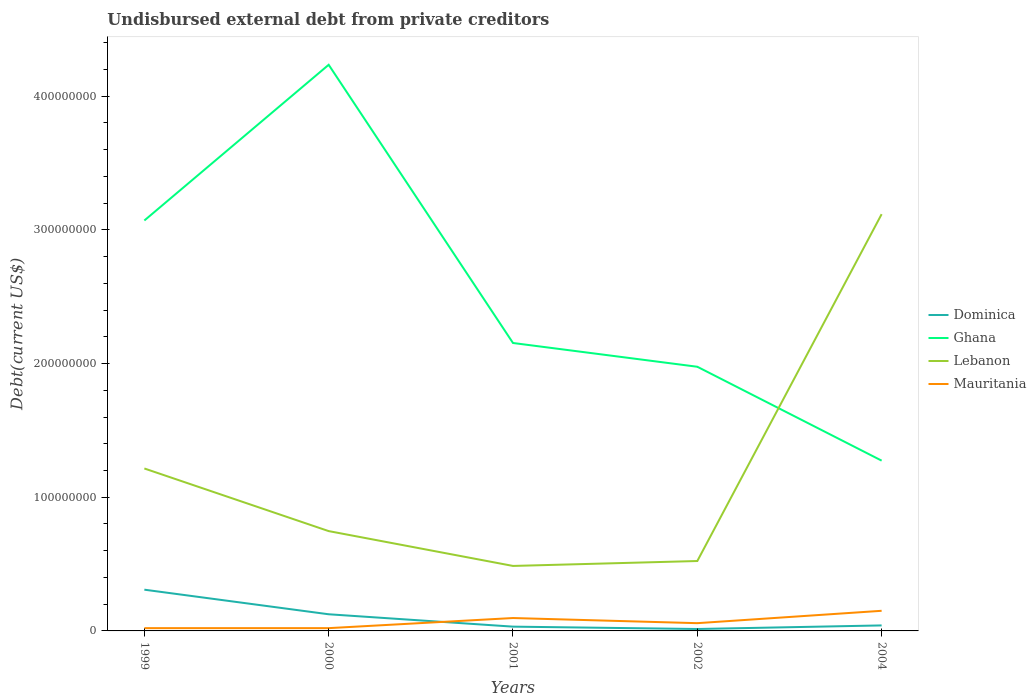How many different coloured lines are there?
Provide a succinct answer. 4. Across all years, what is the maximum total debt in Dominica?
Keep it short and to the point. 1.44e+06. In which year was the total debt in Mauritania maximum?
Provide a short and direct response. 1999. What is the total total debt in Lebanon in the graph?
Make the answer very short. -2.63e+08. What is the difference between the highest and the second highest total debt in Lebanon?
Provide a short and direct response. 2.63e+08. Is the total debt in Mauritania strictly greater than the total debt in Ghana over the years?
Make the answer very short. Yes. What is the difference between two consecutive major ticks on the Y-axis?
Give a very brief answer. 1.00e+08. Are the values on the major ticks of Y-axis written in scientific E-notation?
Your answer should be compact. No. Does the graph contain grids?
Keep it short and to the point. No. How many legend labels are there?
Your response must be concise. 4. How are the legend labels stacked?
Your answer should be very brief. Vertical. What is the title of the graph?
Provide a short and direct response. Undisbursed external debt from private creditors. Does "Kosovo" appear as one of the legend labels in the graph?
Offer a very short reply. No. What is the label or title of the X-axis?
Ensure brevity in your answer.  Years. What is the label or title of the Y-axis?
Your answer should be compact. Debt(current US$). What is the Debt(current US$) of Dominica in 1999?
Provide a succinct answer. 3.08e+07. What is the Debt(current US$) of Ghana in 1999?
Ensure brevity in your answer.  3.07e+08. What is the Debt(current US$) of Lebanon in 1999?
Offer a terse response. 1.22e+08. What is the Debt(current US$) of Mauritania in 1999?
Provide a short and direct response. 2.08e+06. What is the Debt(current US$) of Dominica in 2000?
Ensure brevity in your answer.  1.25e+07. What is the Debt(current US$) of Ghana in 2000?
Provide a short and direct response. 4.23e+08. What is the Debt(current US$) in Lebanon in 2000?
Provide a succinct answer. 7.47e+07. What is the Debt(current US$) in Mauritania in 2000?
Your answer should be very brief. 2.08e+06. What is the Debt(current US$) in Dominica in 2001?
Make the answer very short. 3.20e+06. What is the Debt(current US$) in Ghana in 2001?
Provide a succinct answer. 2.15e+08. What is the Debt(current US$) in Lebanon in 2001?
Your response must be concise. 4.86e+07. What is the Debt(current US$) of Mauritania in 2001?
Provide a succinct answer. 9.64e+06. What is the Debt(current US$) in Dominica in 2002?
Offer a terse response. 1.44e+06. What is the Debt(current US$) of Ghana in 2002?
Provide a short and direct response. 1.98e+08. What is the Debt(current US$) in Lebanon in 2002?
Give a very brief answer. 5.23e+07. What is the Debt(current US$) in Mauritania in 2002?
Your response must be concise. 5.80e+06. What is the Debt(current US$) in Dominica in 2004?
Your answer should be compact. 4.12e+06. What is the Debt(current US$) of Ghana in 2004?
Keep it short and to the point. 1.27e+08. What is the Debt(current US$) in Lebanon in 2004?
Your response must be concise. 3.12e+08. What is the Debt(current US$) in Mauritania in 2004?
Provide a succinct answer. 1.51e+07. Across all years, what is the maximum Debt(current US$) of Dominica?
Make the answer very short. 3.08e+07. Across all years, what is the maximum Debt(current US$) in Ghana?
Provide a short and direct response. 4.23e+08. Across all years, what is the maximum Debt(current US$) of Lebanon?
Make the answer very short. 3.12e+08. Across all years, what is the maximum Debt(current US$) of Mauritania?
Your response must be concise. 1.51e+07. Across all years, what is the minimum Debt(current US$) in Dominica?
Provide a succinct answer. 1.44e+06. Across all years, what is the minimum Debt(current US$) of Ghana?
Provide a succinct answer. 1.27e+08. Across all years, what is the minimum Debt(current US$) in Lebanon?
Your answer should be very brief. 4.86e+07. Across all years, what is the minimum Debt(current US$) in Mauritania?
Offer a terse response. 2.08e+06. What is the total Debt(current US$) of Dominica in the graph?
Your answer should be very brief. 5.21e+07. What is the total Debt(current US$) in Ghana in the graph?
Give a very brief answer. 1.27e+09. What is the total Debt(current US$) of Lebanon in the graph?
Make the answer very short. 6.09e+08. What is the total Debt(current US$) of Mauritania in the graph?
Provide a short and direct response. 3.47e+07. What is the difference between the Debt(current US$) in Dominica in 1999 and that in 2000?
Offer a terse response. 1.84e+07. What is the difference between the Debt(current US$) in Ghana in 1999 and that in 2000?
Offer a terse response. -1.16e+08. What is the difference between the Debt(current US$) in Lebanon in 1999 and that in 2000?
Ensure brevity in your answer.  4.68e+07. What is the difference between the Debt(current US$) in Dominica in 1999 and that in 2001?
Give a very brief answer. 2.76e+07. What is the difference between the Debt(current US$) in Ghana in 1999 and that in 2001?
Your answer should be compact. 9.16e+07. What is the difference between the Debt(current US$) in Lebanon in 1999 and that in 2001?
Your answer should be very brief. 7.29e+07. What is the difference between the Debt(current US$) in Mauritania in 1999 and that in 2001?
Your answer should be compact. -7.55e+06. What is the difference between the Debt(current US$) of Dominica in 1999 and that in 2002?
Your response must be concise. 2.94e+07. What is the difference between the Debt(current US$) in Ghana in 1999 and that in 2002?
Your answer should be very brief. 1.09e+08. What is the difference between the Debt(current US$) of Lebanon in 1999 and that in 2002?
Provide a succinct answer. 6.92e+07. What is the difference between the Debt(current US$) in Mauritania in 1999 and that in 2002?
Keep it short and to the point. -3.72e+06. What is the difference between the Debt(current US$) in Dominica in 1999 and that in 2004?
Make the answer very short. 2.67e+07. What is the difference between the Debt(current US$) of Ghana in 1999 and that in 2004?
Your response must be concise. 1.80e+08. What is the difference between the Debt(current US$) in Lebanon in 1999 and that in 2004?
Make the answer very short. -1.90e+08. What is the difference between the Debt(current US$) of Mauritania in 1999 and that in 2004?
Your response must be concise. -1.30e+07. What is the difference between the Debt(current US$) in Dominica in 2000 and that in 2001?
Make the answer very short. 9.25e+06. What is the difference between the Debt(current US$) of Ghana in 2000 and that in 2001?
Provide a succinct answer. 2.08e+08. What is the difference between the Debt(current US$) of Lebanon in 2000 and that in 2001?
Offer a terse response. 2.61e+07. What is the difference between the Debt(current US$) in Mauritania in 2000 and that in 2001?
Provide a short and direct response. -7.55e+06. What is the difference between the Debt(current US$) of Dominica in 2000 and that in 2002?
Your answer should be very brief. 1.10e+07. What is the difference between the Debt(current US$) in Ghana in 2000 and that in 2002?
Your answer should be compact. 2.26e+08. What is the difference between the Debt(current US$) of Lebanon in 2000 and that in 2002?
Offer a terse response. 2.24e+07. What is the difference between the Debt(current US$) of Mauritania in 2000 and that in 2002?
Provide a short and direct response. -3.72e+06. What is the difference between the Debt(current US$) of Dominica in 2000 and that in 2004?
Provide a short and direct response. 8.34e+06. What is the difference between the Debt(current US$) of Ghana in 2000 and that in 2004?
Ensure brevity in your answer.  2.96e+08. What is the difference between the Debt(current US$) in Lebanon in 2000 and that in 2004?
Provide a short and direct response. -2.37e+08. What is the difference between the Debt(current US$) in Mauritania in 2000 and that in 2004?
Your response must be concise. -1.30e+07. What is the difference between the Debt(current US$) of Dominica in 2001 and that in 2002?
Your answer should be compact. 1.76e+06. What is the difference between the Debt(current US$) of Ghana in 2001 and that in 2002?
Provide a succinct answer. 1.78e+07. What is the difference between the Debt(current US$) of Lebanon in 2001 and that in 2002?
Provide a succinct answer. -3.68e+06. What is the difference between the Debt(current US$) in Mauritania in 2001 and that in 2002?
Give a very brief answer. 3.84e+06. What is the difference between the Debt(current US$) of Dominica in 2001 and that in 2004?
Make the answer very short. -9.12e+05. What is the difference between the Debt(current US$) in Ghana in 2001 and that in 2004?
Make the answer very short. 8.80e+07. What is the difference between the Debt(current US$) in Lebanon in 2001 and that in 2004?
Your response must be concise. -2.63e+08. What is the difference between the Debt(current US$) of Mauritania in 2001 and that in 2004?
Provide a succinct answer. -5.41e+06. What is the difference between the Debt(current US$) in Dominica in 2002 and that in 2004?
Give a very brief answer. -2.68e+06. What is the difference between the Debt(current US$) of Ghana in 2002 and that in 2004?
Make the answer very short. 7.02e+07. What is the difference between the Debt(current US$) in Lebanon in 2002 and that in 2004?
Your answer should be compact. -2.59e+08. What is the difference between the Debt(current US$) of Mauritania in 2002 and that in 2004?
Your answer should be compact. -9.25e+06. What is the difference between the Debt(current US$) in Dominica in 1999 and the Debt(current US$) in Ghana in 2000?
Offer a very short reply. -3.93e+08. What is the difference between the Debt(current US$) in Dominica in 1999 and the Debt(current US$) in Lebanon in 2000?
Offer a terse response. -4.38e+07. What is the difference between the Debt(current US$) in Dominica in 1999 and the Debt(current US$) in Mauritania in 2000?
Your answer should be compact. 2.88e+07. What is the difference between the Debt(current US$) of Ghana in 1999 and the Debt(current US$) of Lebanon in 2000?
Make the answer very short. 2.32e+08. What is the difference between the Debt(current US$) in Ghana in 1999 and the Debt(current US$) in Mauritania in 2000?
Your answer should be very brief. 3.05e+08. What is the difference between the Debt(current US$) in Lebanon in 1999 and the Debt(current US$) in Mauritania in 2000?
Your response must be concise. 1.19e+08. What is the difference between the Debt(current US$) of Dominica in 1999 and the Debt(current US$) of Ghana in 2001?
Offer a terse response. -1.85e+08. What is the difference between the Debt(current US$) of Dominica in 1999 and the Debt(current US$) of Lebanon in 2001?
Your answer should be very brief. -1.78e+07. What is the difference between the Debt(current US$) of Dominica in 1999 and the Debt(current US$) of Mauritania in 2001?
Give a very brief answer. 2.12e+07. What is the difference between the Debt(current US$) in Ghana in 1999 and the Debt(current US$) in Lebanon in 2001?
Give a very brief answer. 2.58e+08. What is the difference between the Debt(current US$) of Ghana in 1999 and the Debt(current US$) of Mauritania in 2001?
Make the answer very short. 2.97e+08. What is the difference between the Debt(current US$) in Lebanon in 1999 and the Debt(current US$) in Mauritania in 2001?
Give a very brief answer. 1.12e+08. What is the difference between the Debt(current US$) of Dominica in 1999 and the Debt(current US$) of Ghana in 2002?
Keep it short and to the point. -1.67e+08. What is the difference between the Debt(current US$) in Dominica in 1999 and the Debt(current US$) in Lebanon in 2002?
Ensure brevity in your answer.  -2.14e+07. What is the difference between the Debt(current US$) of Dominica in 1999 and the Debt(current US$) of Mauritania in 2002?
Make the answer very short. 2.50e+07. What is the difference between the Debt(current US$) of Ghana in 1999 and the Debt(current US$) of Lebanon in 2002?
Provide a short and direct response. 2.55e+08. What is the difference between the Debt(current US$) of Ghana in 1999 and the Debt(current US$) of Mauritania in 2002?
Offer a very short reply. 3.01e+08. What is the difference between the Debt(current US$) in Lebanon in 1999 and the Debt(current US$) in Mauritania in 2002?
Provide a succinct answer. 1.16e+08. What is the difference between the Debt(current US$) in Dominica in 1999 and the Debt(current US$) in Ghana in 2004?
Ensure brevity in your answer.  -9.65e+07. What is the difference between the Debt(current US$) of Dominica in 1999 and the Debt(current US$) of Lebanon in 2004?
Give a very brief answer. -2.81e+08. What is the difference between the Debt(current US$) of Dominica in 1999 and the Debt(current US$) of Mauritania in 2004?
Ensure brevity in your answer.  1.58e+07. What is the difference between the Debt(current US$) of Ghana in 1999 and the Debt(current US$) of Lebanon in 2004?
Offer a terse response. -4.74e+06. What is the difference between the Debt(current US$) in Ghana in 1999 and the Debt(current US$) in Mauritania in 2004?
Keep it short and to the point. 2.92e+08. What is the difference between the Debt(current US$) in Lebanon in 1999 and the Debt(current US$) in Mauritania in 2004?
Provide a short and direct response. 1.06e+08. What is the difference between the Debt(current US$) of Dominica in 2000 and the Debt(current US$) of Ghana in 2001?
Your answer should be compact. -2.03e+08. What is the difference between the Debt(current US$) of Dominica in 2000 and the Debt(current US$) of Lebanon in 2001?
Your answer should be compact. -3.61e+07. What is the difference between the Debt(current US$) of Dominica in 2000 and the Debt(current US$) of Mauritania in 2001?
Offer a very short reply. 2.82e+06. What is the difference between the Debt(current US$) of Ghana in 2000 and the Debt(current US$) of Lebanon in 2001?
Your response must be concise. 3.75e+08. What is the difference between the Debt(current US$) of Ghana in 2000 and the Debt(current US$) of Mauritania in 2001?
Ensure brevity in your answer.  4.14e+08. What is the difference between the Debt(current US$) in Lebanon in 2000 and the Debt(current US$) in Mauritania in 2001?
Provide a succinct answer. 6.50e+07. What is the difference between the Debt(current US$) in Dominica in 2000 and the Debt(current US$) in Ghana in 2002?
Ensure brevity in your answer.  -1.85e+08. What is the difference between the Debt(current US$) of Dominica in 2000 and the Debt(current US$) of Lebanon in 2002?
Make the answer very short. -3.98e+07. What is the difference between the Debt(current US$) in Dominica in 2000 and the Debt(current US$) in Mauritania in 2002?
Provide a succinct answer. 6.66e+06. What is the difference between the Debt(current US$) in Ghana in 2000 and the Debt(current US$) in Lebanon in 2002?
Keep it short and to the point. 3.71e+08. What is the difference between the Debt(current US$) of Ghana in 2000 and the Debt(current US$) of Mauritania in 2002?
Offer a very short reply. 4.18e+08. What is the difference between the Debt(current US$) of Lebanon in 2000 and the Debt(current US$) of Mauritania in 2002?
Offer a very short reply. 6.89e+07. What is the difference between the Debt(current US$) in Dominica in 2000 and the Debt(current US$) in Ghana in 2004?
Make the answer very short. -1.15e+08. What is the difference between the Debt(current US$) of Dominica in 2000 and the Debt(current US$) of Lebanon in 2004?
Keep it short and to the point. -2.99e+08. What is the difference between the Debt(current US$) in Dominica in 2000 and the Debt(current US$) in Mauritania in 2004?
Your answer should be very brief. -2.59e+06. What is the difference between the Debt(current US$) in Ghana in 2000 and the Debt(current US$) in Lebanon in 2004?
Ensure brevity in your answer.  1.12e+08. What is the difference between the Debt(current US$) of Ghana in 2000 and the Debt(current US$) of Mauritania in 2004?
Keep it short and to the point. 4.08e+08. What is the difference between the Debt(current US$) in Lebanon in 2000 and the Debt(current US$) in Mauritania in 2004?
Ensure brevity in your answer.  5.96e+07. What is the difference between the Debt(current US$) in Dominica in 2001 and the Debt(current US$) in Ghana in 2002?
Provide a short and direct response. -1.94e+08. What is the difference between the Debt(current US$) of Dominica in 2001 and the Debt(current US$) of Lebanon in 2002?
Keep it short and to the point. -4.91e+07. What is the difference between the Debt(current US$) of Dominica in 2001 and the Debt(current US$) of Mauritania in 2002?
Keep it short and to the point. -2.60e+06. What is the difference between the Debt(current US$) in Ghana in 2001 and the Debt(current US$) in Lebanon in 2002?
Your response must be concise. 1.63e+08. What is the difference between the Debt(current US$) of Ghana in 2001 and the Debt(current US$) of Mauritania in 2002?
Provide a short and direct response. 2.10e+08. What is the difference between the Debt(current US$) of Lebanon in 2001 and the Debt(current US$) of Mauritania in 2002?
Make the answer very short. 4.28e+07. What is the difference between the Debt(current US$) in Dominica in 2001 and the Debt(current US$) in Ghana in 2004?
Your answer should be compact. -1.24e+08. What is the difference between the Debt(current US$) of Dominica in 2001 and the Debt(current US$) of Lebanon in 2004?
Give a very brief answer. -3.09e+08. What is the difference between the Debt(current US$) of Dominica in 2001 and the Debt(current US$) of Mauritania in 2004?
Provide a succinct answer. -1.18e+07. What is the difference between the Debt(current US$) in Ghana in 2001 and the Debt(current US$) in Lebanon in 2004?
Your answer should be compact. -9.64e+07. What is the difference between the Debt(current US$) in Ghana in 2001 and the Debt(current US$) in Mauritania in 2004?
Provide a succinct answer. 2.00e+08. What is the difference between the Debt(current US$) of Lebanon in 2001 and the Debt(current US$) of Mauritania in 2004?
Give a very brief answer. 3.36e+07. What is the difference between the Debt(current US$) in Dominica in 2002 and the Debt(current US$) in Ghana in 2004?
Give a very brief answer. -1.26e+08. What is the difference between the Debt(current US$) of Dominica in 2002 and the Debt(current US$) of Lebanon in 2004?
Your answer should be compact. -3.10e+08. What is the difference between the Debt(current US$) of Dominica in 2002 and the Debt(current US$) of Mauritania in 2004?
Provide a short and direct response. -1.36e+07. What is the difference between the Debt(current US$) in Ghana in 2002 and the Debt(current US$) in Lebanon in 2004?
Ensure brevity in your answer.  -1.14e+08. What is the difference between the Debt(current US$) in Ghana in 2002 and the Debt(current US$) in Mauritania in 2004?
Provide a succinct answer. 1.83e+08. What is the difference between the Debt(current US$) in Lebanon in 2002 and the Debt(current US$) in Mauritania in 2004?
Your response must be concise. 3.72e+07. What is the average Debt(current US$) of Dominica per year?
Offer a terse response. 1.04e+07. What is the average Debt(current US$) of Ghana per year?
Offer a terse response. 2.54e+08. What is the average Debt(current US$) of Lebanon per year?
Provide a succinct answer. 1.22e+08. What is the average Debt(current US$) in Mauritania per year?
Your answer should be very brief. 6.93e+06. In the year 1999, what is the difference between the Debt(current US$) in Dominica and Debt(current US$) in Ghana?
Ensure brevity in your answer.  -2.76e+08. In the year 1999, what is the difference between the Debt(current US$) in Dominica and Debt(current US$) in Lebanon?
Your response must be concise. -9.07e+07. In the year 1999, what is the difference between the Debt(current US$) in Dominica and Debt(current US$) in Mauritania?
Offer a terse response. 2.88e+07. In the year 1999, what is the difference between the Debt(current US$) in Ghana and Debt(current US$) in Lebanon?
Keep it short and to the point. 1.85e+08. In the year 1999, what is the difference between the Debt(current US$) in Ghana and Debt(current US$) in Mauritania?
Offer a very short reply. 3.05e+08. In the year 1999, what is the difference between the Debt(current US$) in Lebanon and Debt(current US$) in Mauritania?
Provide a succinct answer. 1.19e+08. In the year 2000, what is the difference between the Debt(current US$) of Dominica and Debt(current US$) of Ghana?
Ensure brevity in your answer.  -4.11e+08. In the year 2000, what is the difference between the Debt(current US$) in Dominica and Debt(current US$) in Lebanon?
Your answer should be compact. -6.22e+07. In the year 2000, what is the difference between the Debt(current US$) in Dominica and Debt(current US$) in Mauritania?
Offer a terse response. 1.04e+07. In the year 2000, what is the difference between the Debt(current US$) of Ghana and Debt(current US$) of Lebanon?
Offer a terse response. 3.49e+08. In the year 2000, what is the difference between the Debt(current US$) of Ghana and Debt(current US$) of Mauritania?
Make the answer very short. 4.21e+08. In the year 2000, what is the difference between the Debt(current US$) in Lebanon and Debt(current US$) in Mauritania?
Make the answer very short. 7.26e+07. In the year 2001, what is the difference between the Debt(current US$) in Dominica and Debt(current US$) in Ghana?
Your answer should be very brief. -2.12e+08. In the year 2001, what is the difference between the Debt(current US$) of Dominica and Debt(current US$) of Lebanon?
Your response must be concise. -4.54e+07. In the year 2001, what is the difference between the Debt(current US$) of Dominica and Debt(current US$) of Mauritania?
Your answer should be compact. -6.43e+06. In the year 2001, what is the difference between the Debt(current US$) of Ghana and Debt(current US$) of Lebanon?
Offer a very short reply. 1.67e+08. In the year 2001, what is the difference between the Debt(current US$) in Ghana and Debt(current US$) in Mauritania?
Offer a terse response. 2.06e+08. In the year 2001, what is the difference between the Debt(current US$) of Lebanon and Debt(current US$) of Mauritania?
Provide a short and direct response. 3.90e+07. In the year 2002, what is the difference between the Debt(current US$) of Dominica and Debt(current US$) of Ghana?
Offer a very short reply. -1.96e+08. In the year 2002, what is the difference between the Debt(current US$) of Dominica and Debt(current US$) of Lebanon?
Offer a very short reply. -5.08e+07. In the year 2002, what is the difference between the Debt(current US$) in Dominica and Debt(current US$) in Mauritania?
Your answer should be very brief. -4.36e+06. In the year 2002, what is the difference between the Debt(current US$) in Ghana and Debt(current US$) in Lebanon?
Keep it short and to the point. 1.45e+08. In the year 2002, what is the difference between the Debt(current US$) in Ghana and Debt(current US$) in Mauritania?
Give a very brief answer. 1.92e+08. In the year 2002, what is the difference between the Debt(current US$) of Lebanon and Debt(current US$) of Mauritania?
Provide a short and direct response. 4.65e+07. In the year 2004, what is the difference between the Debt(current US$) of Dominica and Debt(current US$) of Ghana?
Your answer should be very brief. -1.23e+08. In the year 2004, what is the difference between the Debt(current US$) in Dominica and Debt(current US$) in Lebanon?
Make the answer very short. -3.08e+08. In the year 2004, what is the difference between the Debt(current US$) in Dominica and Debt(current US$) in Mauritania?
Ensure brevity in your answer.  -1.09e+07. In the year 2004, what is the difference between the Debt(current US$) in Ghana and Debt(current US$) in Lebanon?
Your answer should be very brief. -1.84e+08. In the year 2004, what is the difference between the Debt(current US$) in Ghana and Debt(current US$) in Mauritania?
Offer a very short reply. 1.12e+08. In the year 2004, what is the difference between the Debt(current US$) in Lebanon and Debt(current US$) in Mauritania?
Keep it short and to the point. 2.97e+08. What is the ratio of the Debt(current US$) of Dominica in 1999 to that in 2000?
Your response must be concise. 2.48. What is the ratio of the Debt(current US$) of Ghana in 1999 to that in 2000?
Your answer should be very brief. 0.72. What is the ratio of the Debt(current US$) of Lebanon in 1999 to that in 2000?
Keep it short and to the point. 1.63. What is the ratio of the Debt(current US$) in Mauritania in 1999 to that in 2000?
Keep it short and to the point. 1. What is the ratio of the Debt(current US$) in Dominica in 1999 to that in 2001?
Your answer should be compact. 9.62. What is the ratio of the Debt(current US$) of Ghana in 1999 to that in 2001?
Provide a short and direct response. 1.43. What is the ratio of the Debt(current US$) in Lebanon in 1999 to that in 2001?
Provide a succinct answer. 2.5. What is the ratio of the Debt(current US$) of Mauritania in 1999 to that in 2001?
Provide a short and direct response. 0.22. What is the ratio of the Debt(current US$) of Dominica in 1999 to that in 2002?
Make the answer very short. 21.39. What is the ratio of the Debt(current US$) of Ghana in 1999 to that in 2002?
Ensure brevity in your answer.  1.55. What is the ratio of the Debt(current US$) in Lebanon in 1999 to that in 2002?
Offer a terse response. 2.32. What is the ratio of the Debt(current US$) in Mauritania in 1999 to that in 2002?
Provide a short and direct response. 0.36. What is the ratio of the Debt(current US$) in Dominica in 1999 to that in 2004?
Ensure brevity in your answer.  7.49. What is the ratio of the Debt(current US$) of Ghana in 1999 to that in 2004?
Provide a short and direct response. 2.41. What is the ratio of the Debt(current US$) of Lebanon in 1999 to that in 2004?
Your response must be concise. 0.39. What is the ratio of the Debt(current US$) of Mauritania in 1999 to that in 2004?
Ensure brevity in your answer.  0.14. What is the ratio of the Debt(current US$) of Dominica in 2000 to that in 2001?
Keep it short and to the point. 3.89. What is the ratio of the Debt(current US$) in Ghana in 2000 to that in 2001?
Ensure brevity in your answer.  1.97. What is the ratio of the Debt(current US$) in Lebanon in 2000 to that in 2001?
Offer a terse response. 1.54. What is the ratio of the Debt(current US$) in Mauritania in 2000 to that in 2001?
Provide a succinct answer. 0.22. What is the ratio of the Debt(current US$) in Dominica in 2000 to that in 2002?
Provide a succinct answer. 8.64. What is the ratio of the Debt(current US$) of Ghana in 2000 to that in 2002?
Keep it short and to the point. 2.14. What is the ratio of the Debt(current US$) in Lebanon in 2000 to that in 2002?
Ensure brevity in your answer.  1.43. What is the ratio of the Debt(current US$) in Mauritania in 2000 to that in 2002?
Provide a succinct answer. 0.36. What is the ratio of the Debt(current US$) in Dominica in 2000 to that in 2004?
Provide a succinct answer. 3.03. What is the ratio of the Debt(current US$) in Ghana in 2000 to that in 2004?
Ensure brevity in your answer.  3.32. What is the ratio of the Debt(current US$) of Lebanon in 2000 to that in 2004?
Provide a succinct answer. 0.24. What is the ratio of the Debt(current US$) in Mauritania in 2000 to that in 2004?
Provide a succinct answer. 0.14. What is the ratio of the Debt(current US$) in Dominica in 2001 to that in 2002?
Your answer should be compact. 2.22. What is the ratio of the Debt(current US$) of Ghana in 2001 to that in 2002?
Make the answer very short. 1.09. What is the ratio of the Debt(current US$) in Lebanon in 2001 to that in 2002?
Your response must be concise. 0.93. What is the ratio of the Debt(current US$) in Mauritania in 2001 to that in 2002?
Offer a terse response. 1.66. What is the ratio of the Debt(current US$) of Dominica in 2001 to that in 2004?
Keep it short and to the point. 0.78. What is the ratio of the Debt(current US$) of Ghana in 2001 to that in 2004?
Your answer should be compact. 1.69. What is the ratio of the Debt(current US$) of Lebanon in 2001 to that in 2004?
Your answer should be compact. 0.16. What is the ratio of the Debt(current US$) of Mauritania in 2001 to that in 2004?
Keep it short and to the point. 0.64. What is the ratio of the Debt(current US$) of Dominica in 2002 to that in 2004?
Offer a terse response. 0.35. What is the ratio of the Debt(current US$) of Ghana in 2002 to that in 2004?
Ensure brevity in your answer.  1.55. What is the ratio of the Debt(current US$) of Lebanon in 2002 to that in 2004?
Make the answer very short. 0.17. What is the ratio of the Debt(current US$) in Mauritania in 2002 to that in 2004?
Your response must be concise. 0.39. What is the difference between the highest and the second highest Debt(current US$) of Dominica?
Keep it short and to the point. 1.84e+07. What is the difference between the highest and the second highest Debt(current US$) of Ghana?
Give a very brief answer. 1.16e+08. What is the difference between the highest and the second highest Debt(current US$) of Lebanon?
Keep it short and to the point. 1.90e+08. What is the difference between the highest and the second highest Debt(current US$) of Mauritania?
Ensure brevity in your answer.  5.41e+06. What is the difference between the highest and the lowest Debt(current US$) in Dominica?
Offer a very short reply. 2.94e+07. What is the difference between the highest and the lowest Debt(current US$) of Ghana?
Offer a very short reply. 2.96e+08. What is the difference between the highest and the lowest Debt(current US$) in Lebanon?
Ensure brevity in your answer.  2.63e+08. What is the difference between the highest and the lowest Debt(current US$) of Mauritania?
Provide a short and direct response. 1.30e+07. 